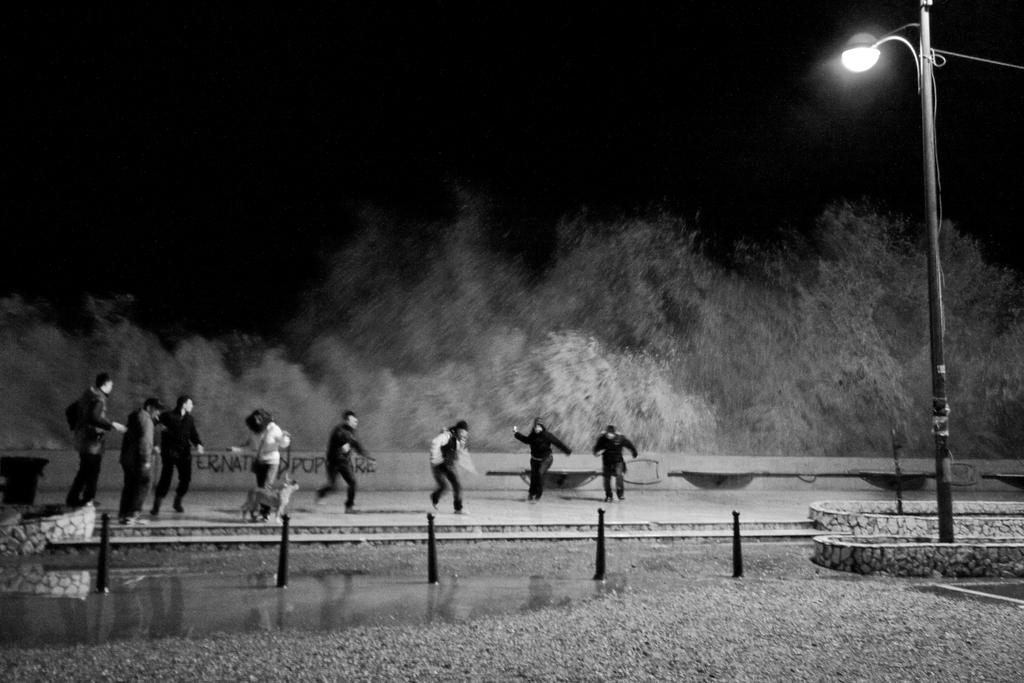Who or what can be seen in the image? There are people in the image. What type of natural environment is present in the image? There are trees and water visible in the image. What is the location of the street lamp in the image? The street lamp is on the right side of the image. What is visible at the top of the image? The sky is visible at the top of the image. How would you describe the lighting in the image? The image appears to be slightly dark. What type of fowl can be seen playing near the street lamp in the image? There is no fowl present in the image, and no playing is depicted. 